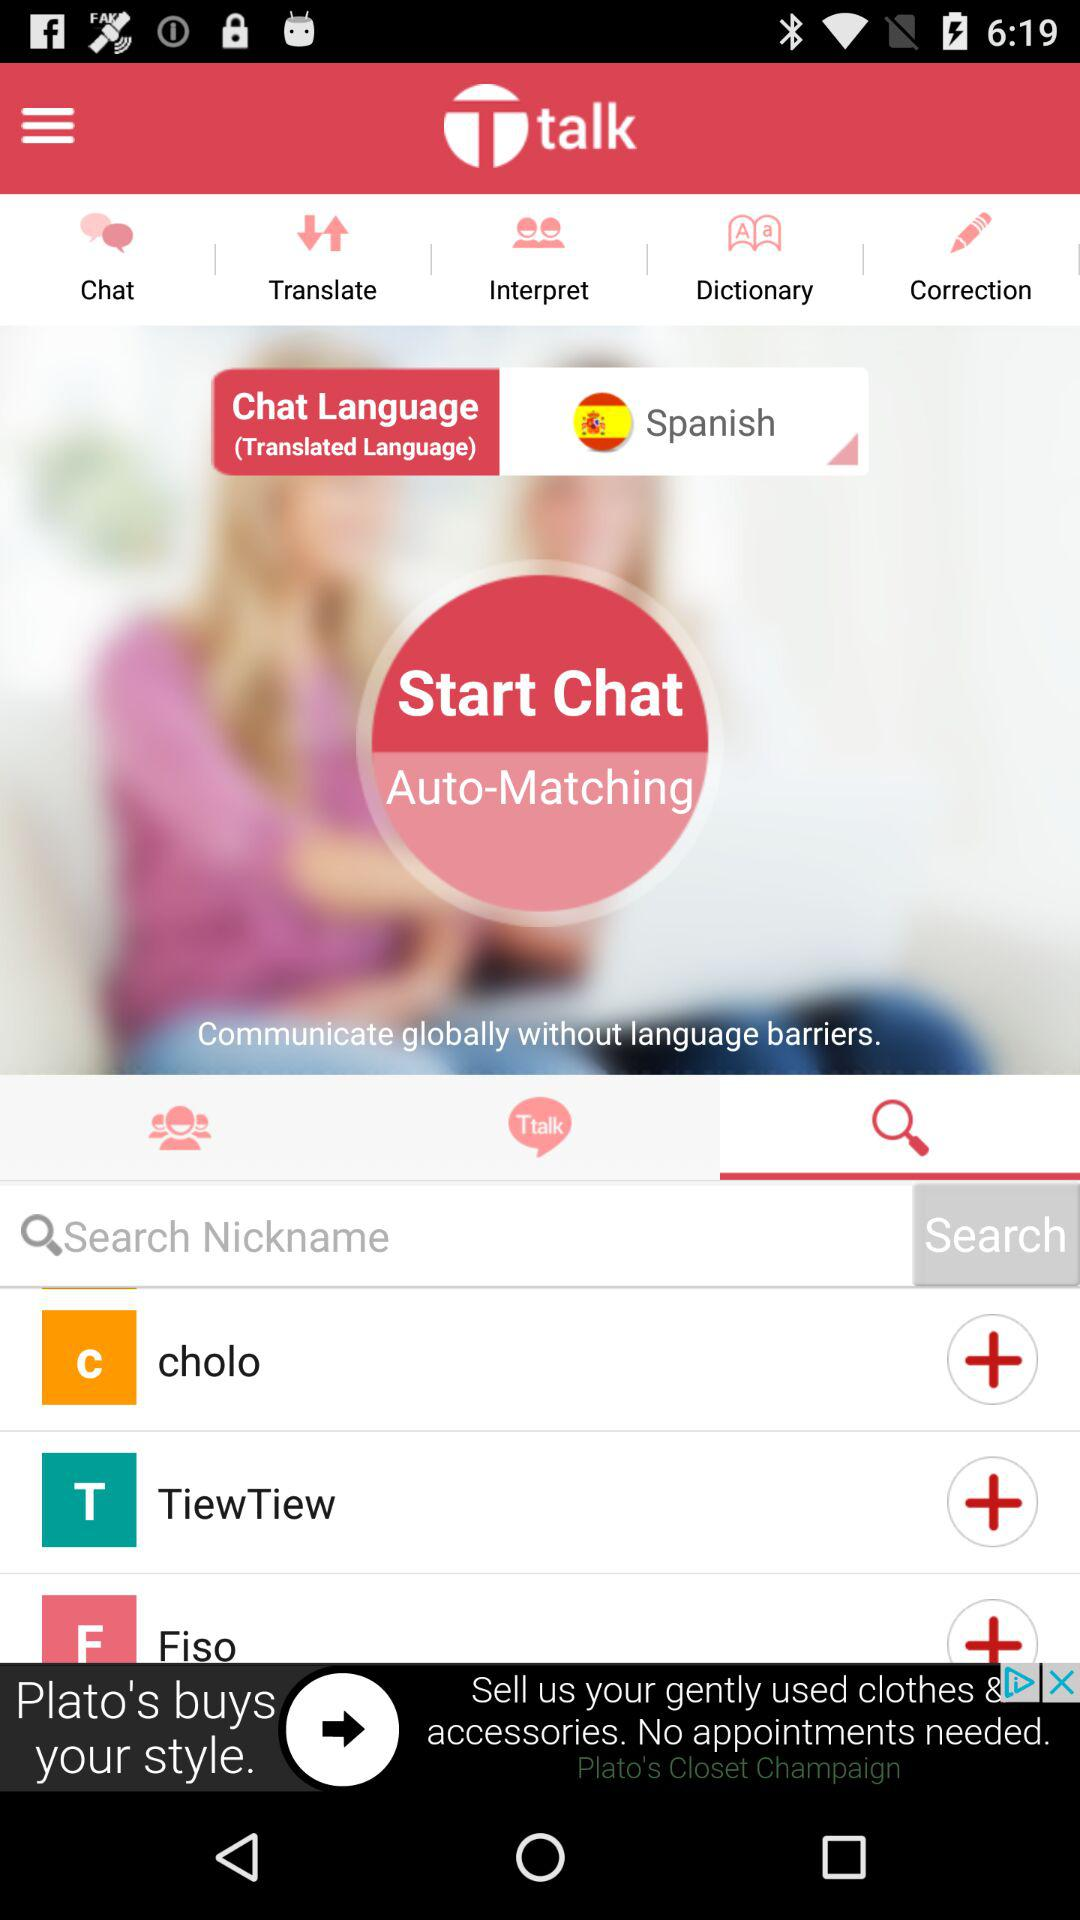What is the chat language? The chat language is Spanish. 